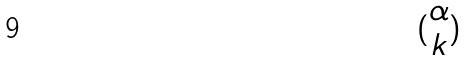Convert formula to latex. <formula><loc_0><loc_0><loc_500><loc_500>( \begin{matrix} \alpha \\ k \end{matrix} )</formula> 